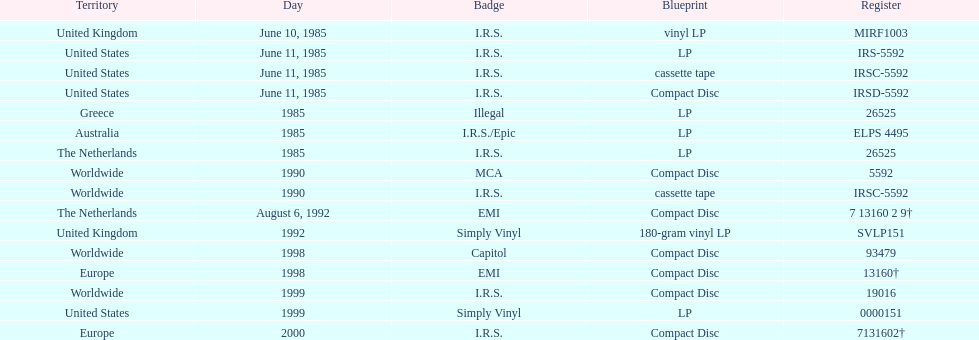What is the highest continuous number of releases in lp format? 3. 